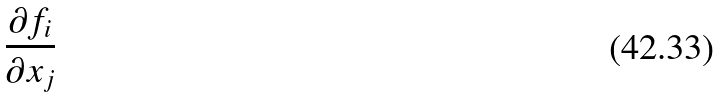Convert formula to latex. <formula><loc_0><loc_0><loc_500><loc_500>\frac { \partial f _ { i } } { \partial x _ { j } }</formula> 